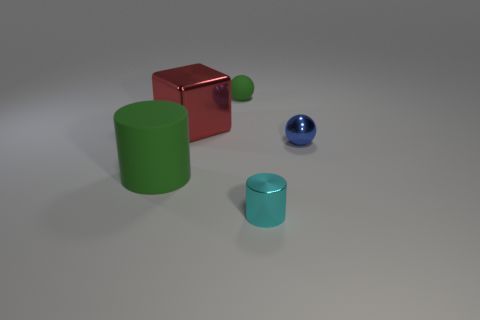Add 4 big metallic blocks. How many objects exist? 9 Subtract all balls. How many objects are left? 3 Subtract all blue balls. How many balls are left? 1 Subtract all blue balls. Subtract all blue cylinders. How many balls are left? 1 Add 3 cylinders. How many cylinders are left? 5 Add 2 big red metal blocks. How many big red metal blocks exist? 3 Subtract 1 green cylinders. How many objects are left? 4 Subtract 2 cylinders. How many cylinders are left? 0 Subtract all brown metallic balls. Subtract all large cubes. How many objects are left? 4 